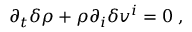Convert formula to latex. <formula><loc_0><loc_0><loc_500><loc_500>\partial _ { t } \delta \rho + \rho \partial _ { i } \delta v ^ { i } = 0 \, ,</formula> 